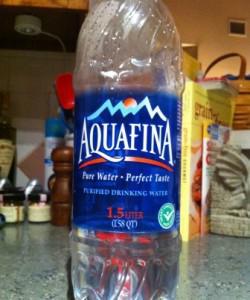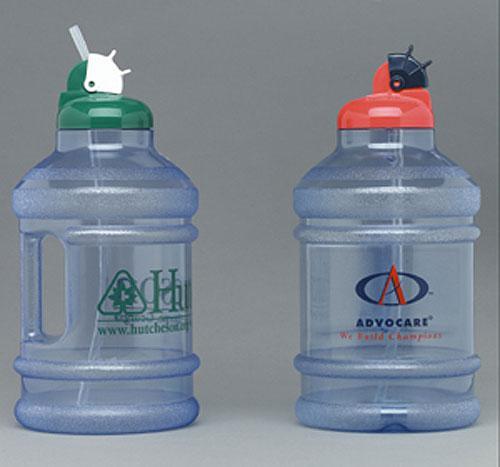The first image is the image on the left, the second image is the image on the right. Examine the images to the left and right. Is the description "At least one image shows a stout jug with a loop-type handle." accurate? Answer yes or no. No. 